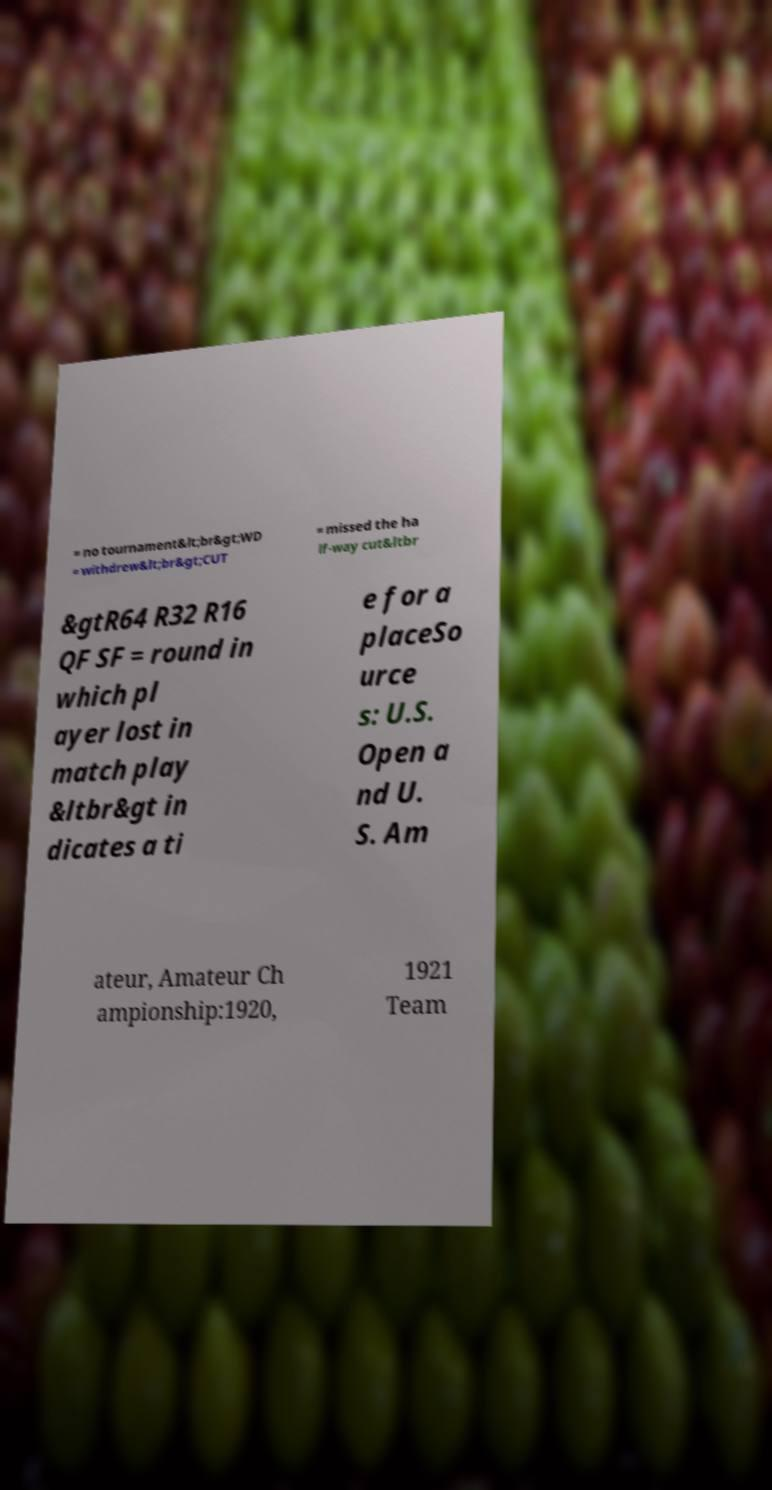Could you assist in decoding the text presented in this image and type it out clearly? = no tournament&lt;br&gt;WD = withdrew&lt;br&gt;CUT = missed the ha lf-way cut&ltbr &gtR64 R32 R16 QF SF = round in which pl ayer lost in match play &ltbr&gt in dicates a ti e for a placeSo urce s: U.S. Open a nd U. S. Am ateur, Amateur Ch ampionship:1920, 1921 Team 